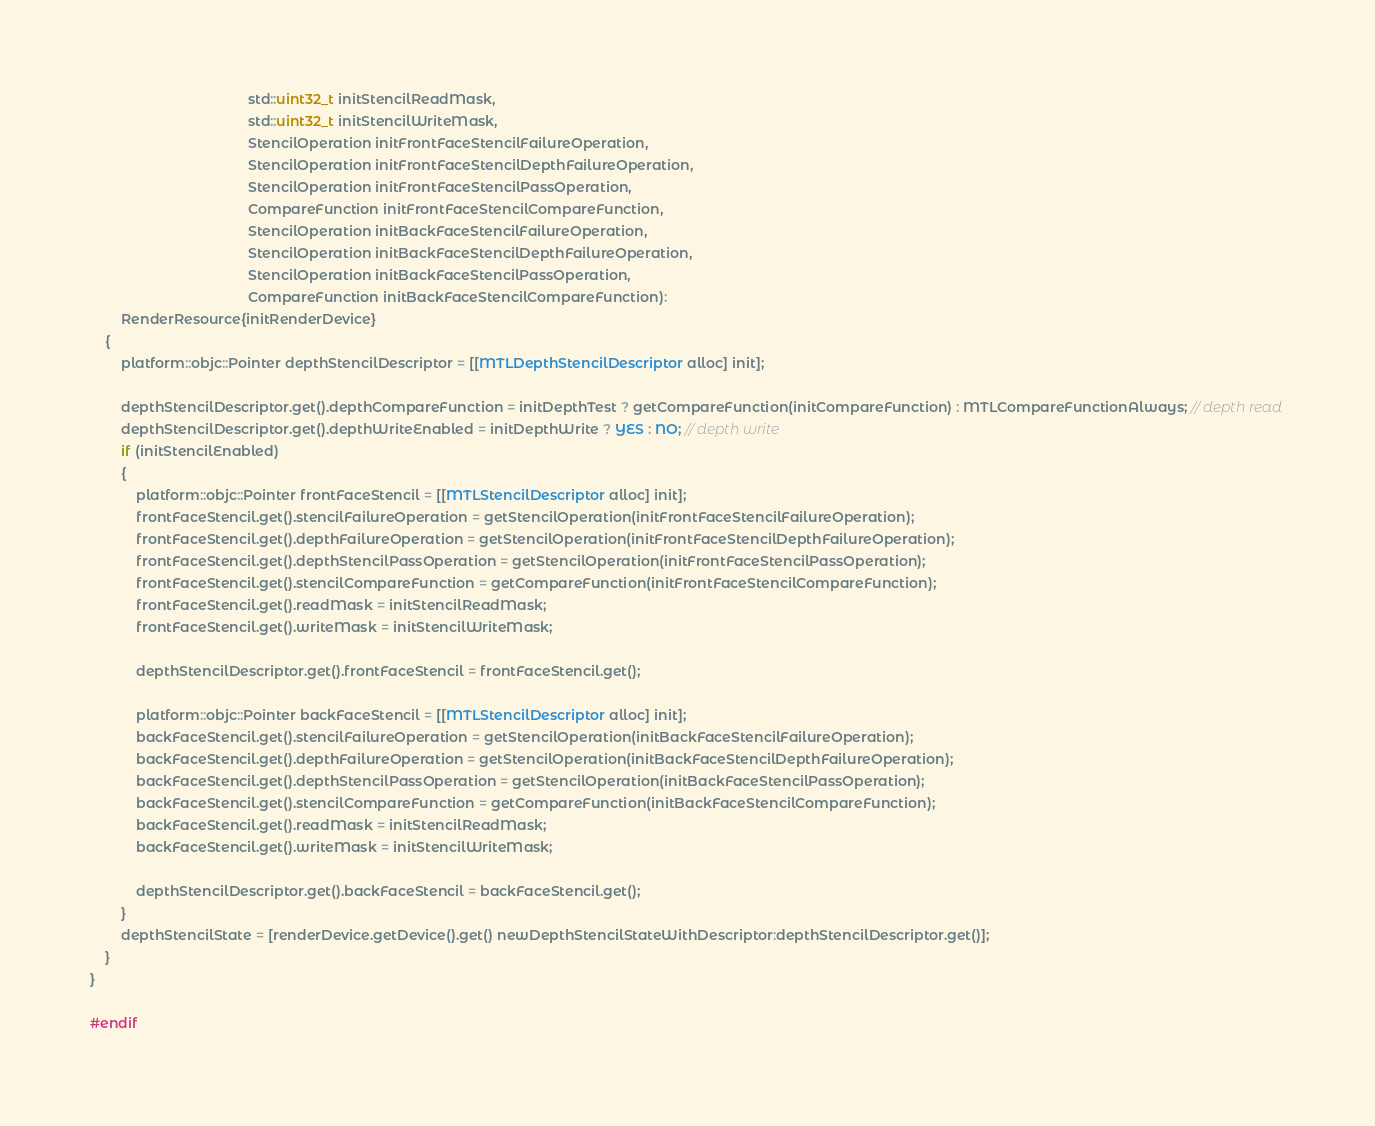<code> <loc_0><loc_0><loc_500><loc_500><_ObjectiveC_>                                         std::uint32_t initStencilReadMask,
                                         std::uint32_t initStencilWriteMask,
                                         StencilOperation initFrontFaceStencilFailureOperation,
                                         StencilOperation initFrontFaceStencilDepthFailureOperation,
                                         StencilOperation initFrontFaceStencilPassOperation,
                                         CompareFunction initFrontFaceStencilCompareFunction,
                                         StencilOperation initBackFaceStencilFailureOperation,
                                         StencilOperation initBackFaceStencilDepthFailureOperation,
                                         StencilOperation initBackFaceStencilPassOperation,
                                         CompareFunction initBackFaceStencilCompareFunction):
        RenderResource{initRenderDevice}
    {
        platform::objc::Pointer depthStencilDescriptor = [[MTLDepthStencilDescriptor alloc] init];

        depthStencilDescriptor.get().depthCompareFunction = initDepthTest ? getCompareFunction(initCompareFunction) : MTLCompareFunctionAlways; // depth read
        depthStencilDescriptor.get().depthWriteEnabled = initDepthWrite ? YES : NO; // depth write
        if (initStencilEnabled)
        {
            platform::objc::Pointer frontFaceStencil = [[MTLStencilDescriptor alloc] init];
            frontFaceStencil.get().stencilFailureOperation = getStencilOperation(initFrontFaceStencilFailureOperation);
            frontFaceStencil.get().depthFailureOperation = getStencilOperation(initFrontFaceStencilDepthFailureOperation);
            frontFaceStencil.get().depthStencilPassOperation = getStencilOperation(initFrontFaceStencilPassOperation);
            frontFaceStencil.get().stencilCompareFunction = getCompareFunction(initFrontFaceStencilCompareFunction);
            frontFaceStencil.get().readMask = initStencilReadMask;
            frontFaceStencil.get().writeMask = initStencilWriteMask;

            depthStencilDescriptor.get().frontFaceStencil = frontFaceStencil.get();

            platform::objc::Pointer backFaceStencil = [[MTLStencilDescriptor alloc] init];
            backFaceStencil.get().stencilFailureOperation = getStencilOperation(initBackFaceStencilFailureOperation);
            backFaceStencil.get().depthFailureOperation = getStencilOperation(initBackFaceStencilDepthFailureOperation);
            backFaceStencil.get().depthStencilPassOperation = getStencilOperation(initBackFaceStencilPassOperation);
            backFaceStencil.get().stencilCompareFunction = getCompareFunction(initBackFaceStencilCompareFunction);
            backFaceStencil.get().readMask = initStencilReadMask;
            backFaceStencil.get().writeMask = initStencilWriteMask;

            depthStencilDescriptor.get().backFaceStencil = backFaceStencil.get();
        }
        depthStencilState = [renderDevice.getDevice().get() newDepthStencilStateWithDescriptor:depthStencilDescriptor.get()];
    }
}

#endif
</code> 